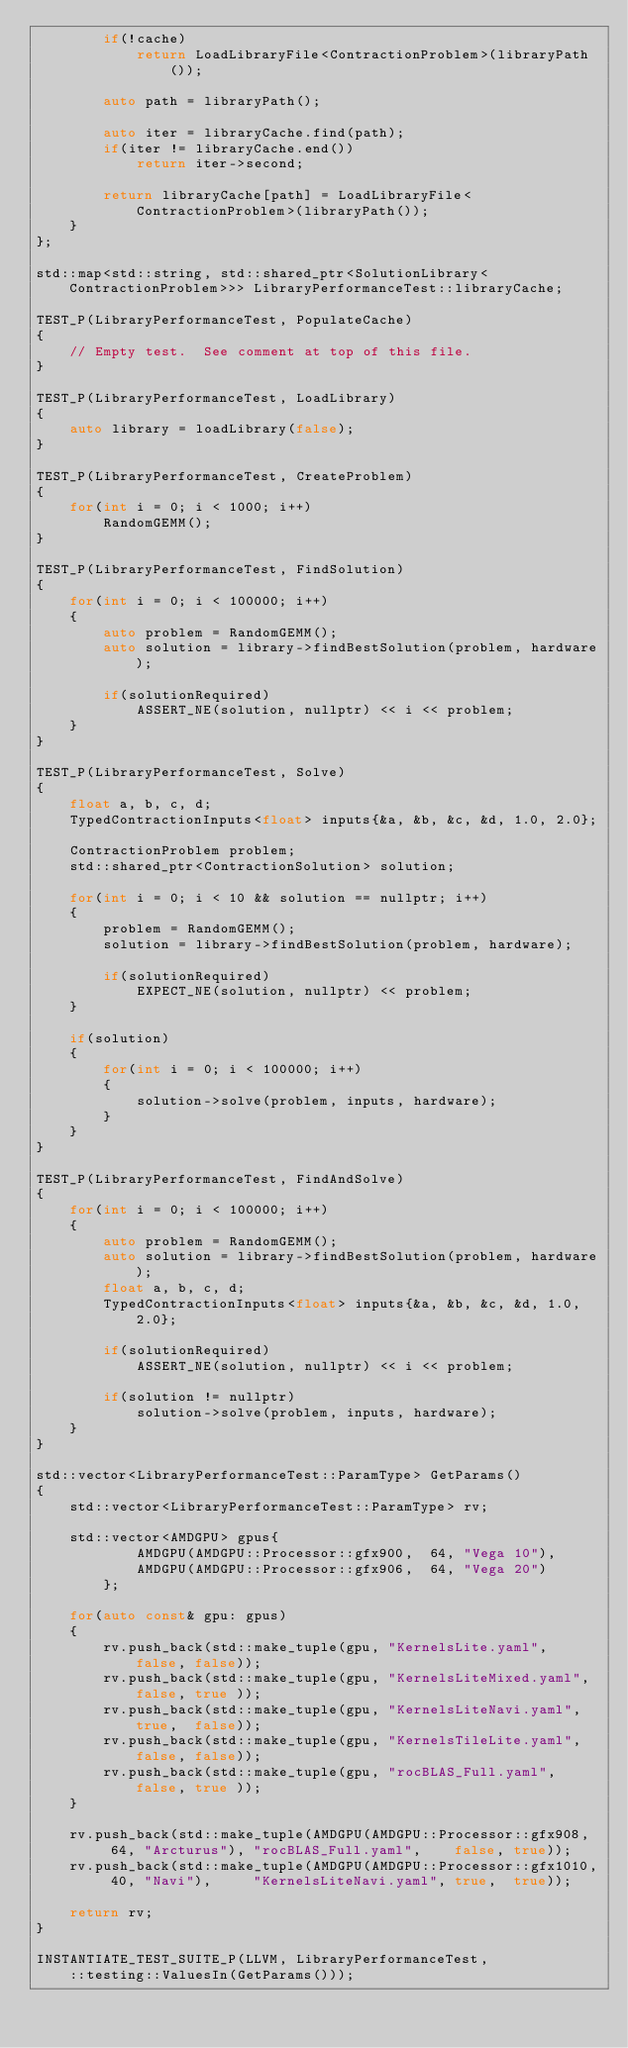Convert code to text. <code><loc_0><loc_0><loc_500><loc_500><_C++_>        if(!cache)
            return LoadLibraryFile<ContractionProblem>(libraryPath());

        auto path = libraryPath();

        auto iter = libraryCache.find(path);
        if(iter != libraryCache.end())
            return iter->second;

        return libraryCache[path] = LoadLibraryFile<ContractionProblem>(libraryPath());
    }
};

std::map<std::string, std::shared_ptr<SolutionLibrary<ContractionProblem>>> LibraryPerformanceTest::libraryCache;

TEST_P(LibraryPerformanceTest, PopulateCache)
{
    // Empty test.  See comment at top of this file.
}

TEST_P(LibraryPerformanceTest, LoadLibrary)
{
    auto library = loadLibrary(false);
}

TEST_P(LibraryPerformanceTest, CreateProblem)
{
    for(int i = 0; i < 1000; i++)
        RandomGEMM();
}

TEST_P(LibraryPerformanceTest, FindSolution)
{
    for(int i = 0; i < 100000; i++)
    {
        auto problem = RandomGEMM();
        auto solution = library->findBestSolution(problem, hardware);

        if(solutionRequired)
            ASSERT_NE(solution, nullptr) << i << problem;
    }
}

TEST_P(LibraryPerformanceTest, Solve)
{
    float a, b, c, d;
    TypedContractionInputs<float> inputs{&a, &b, &c, &d, 1.0, 2.0};

    ContractionProblem problem;
    std::shared_ptr<ContractionSolution> solution;

    for(int i = 0; i < 10 && solution == nullptr; i++)
    {
        problem = RandomGEMM();
        solution = library->findBestSolution(problem, hardware);

        if(solutionRequired)
            EXPECT_NE(solution, nullptr) << problem;
    }

    if(solution)
    {
        for(int i = 0; i < 100000; i++)
        {
            solution->solve(problem, inputs, hardware);
        }
    }
}

TEST_P(LibraryPerformanceTest, FindAndSolve)
{
    for(int i = 0; i < 100000; i++)
    {
        auto problem = RandomGEMM();
        auto solution = library->findBestSolution(problem, hardware);
        float a, b, c, d;
        TypedContractionInputs<float> inputs{&a, &b, &c, &d, 1.0, 2.0};

        if(solutionRequired)
            ASSERT_NE(solution, nullptr) << i << problem;

        if(solution != nullptr)
            solution->solve(problem, inputs, hardware);
    }
}

std::vector<LibraryPerformanceTest::ParamType> GetParams()
{
    std::vector<LibraryPerformanceTest::ParamType> rv;

    std::vector<AMDGPU> gpus{
            AMDGPU(AMDGPU::Processor::gfx900,  64, "Vega 10"),
            AMDGPU(AMDGPU::Processor::gfx906,  64, "Vega 20")
        };

    for(auto const& gpu: gpus)
    {
        rv.push_back(std::make_tuple(gpu, "KernelsLite.yaml",      false, false));
        rv.push_back(std::make_tuple(gpu, "KernelsLiteMixed.yaml", false, true ));
        rv.push_back(std::make_tuple(gpu, "KernelsLiteNavi.yaml",  true,  false));
        rv.push_back(std::make_tuple(gpu, "KernelsTileLite.yaml",  false, false));
        rv.push_back(std::make_tuple(gpu, "rocBLAS_Full.yaml",     false, true ));
    }

    rv.push_back(std::make_tuple(AMDGPU(AMDGPU::Processor::gfx908,  64, "Arcturus"), "rocBLAS_Full.yaml",    false, true));
    rv.push_back(std::make_tuple(AMDGPU(AMDGPU::Processor::gfx1010, 40, "Navi"),     "KernelsLiteNavi.yaml", true,  true));

    return rv;
}

INSTANTIATE_TEST_SUITE_P(LLVM, LibraryPerformanceTest,
    ::testing::ValuesIn(GetParams()));

</code> 